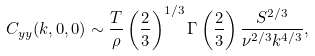Convert formula to latex. <formula><loc_0><loc_0><loc_500><loc_500>C _ { y y } ( k , 0 , 0 ) \sim \frac { T } { \rho } \left ( \frac { 2 } { 3 } \right ) ^ { 1 / 3 } \Gamma \left ( \frac { 2 } { 3 } \right ) \frac { S ^ { 2 / 3 } } { \nu ^ { 2 / 3 } k ^ { 4 / 3 } } ,</formula> 